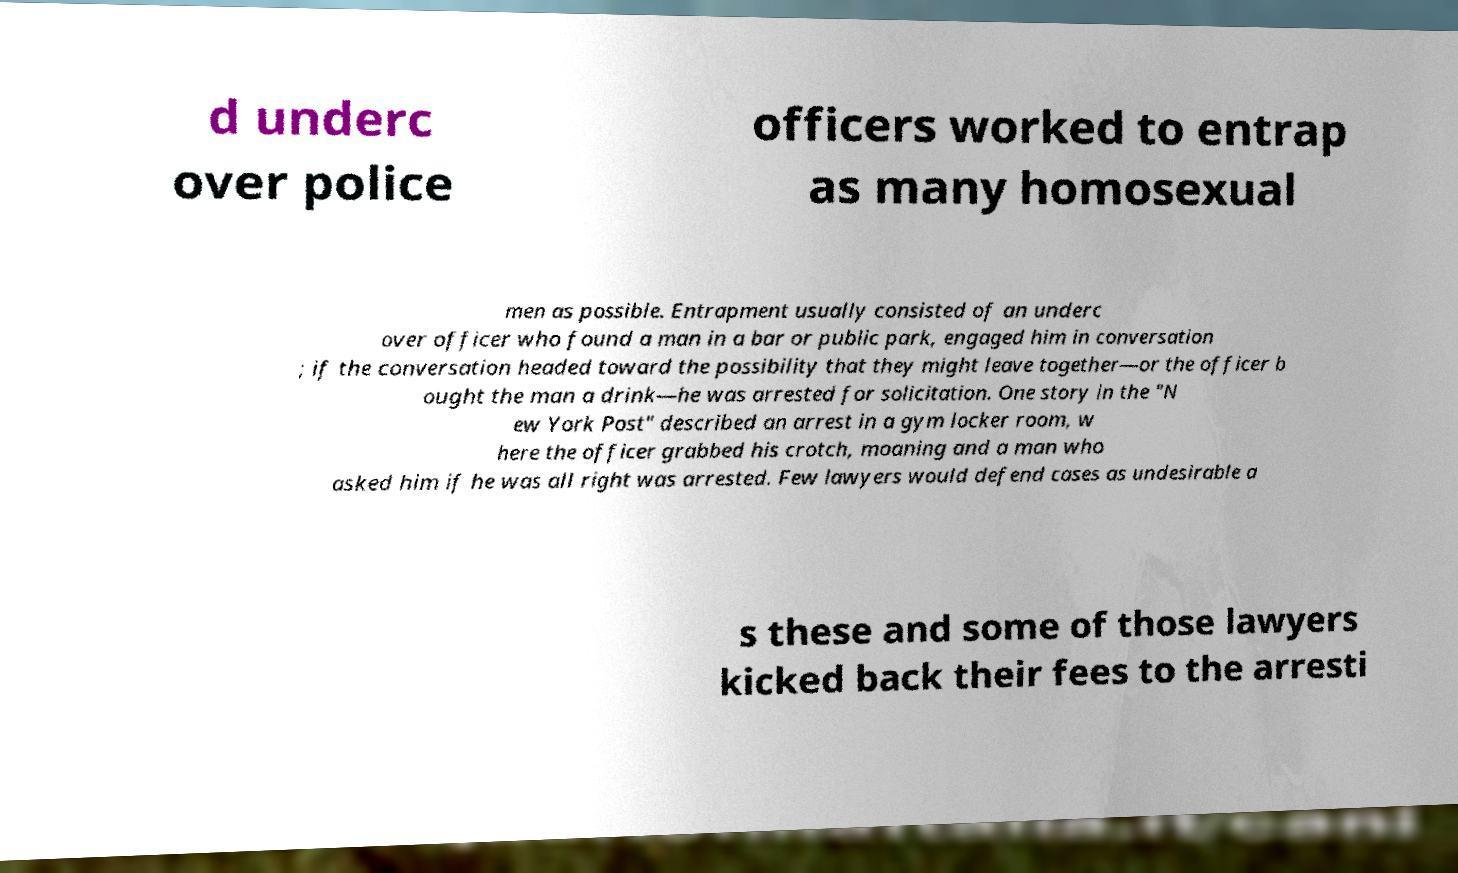What messages or text are displayed in this image? I need them in a readable, typed format. d underc over police officers worked to entrap as many homosexual men as possible. Entrapment usually consisted of an underc over officer who found a man in a bar or public park, engaged him in conversation ; if the conversation headed toward the possibility that they might leave together—or the officer b ought the man a drink—he was arrested for solicitation. One story in the "N ew York Post" described an arrest in a gym locker room, w here the officer grabbed his crotch, moaning and a man who asked him if he was all right was arrested. Few lawyers would defend cases as undesirable a s these and some of those lawyers kicked back their fees to the arresti 